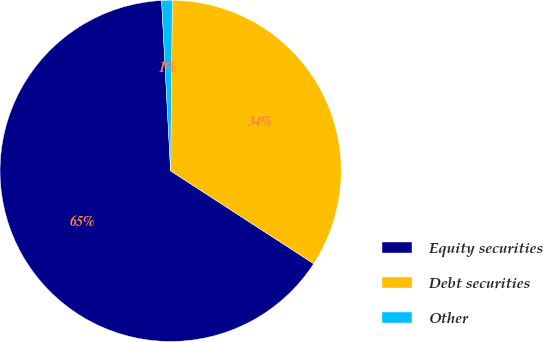Convert chart to OTSL. <chart><loc_0><loc_0><loc_500><loc_500><pie_chart><fcel>Equity securities<fcel>Debt securities<fcel>Other<nl><fcel>65.0%<fcel>34.0%<fcel>1.0%<nl></chart> 